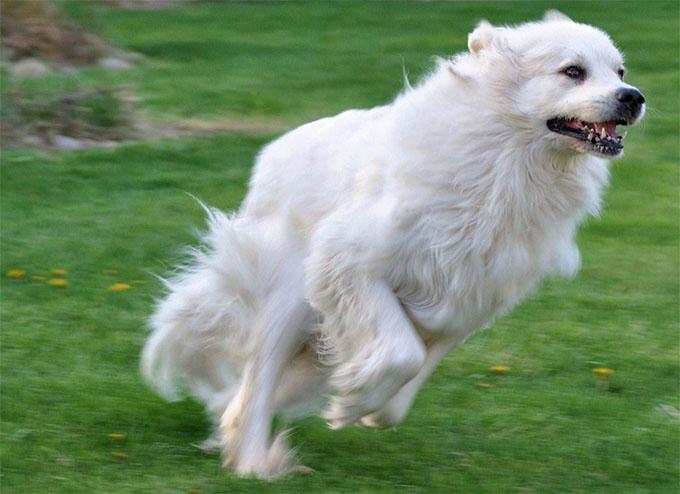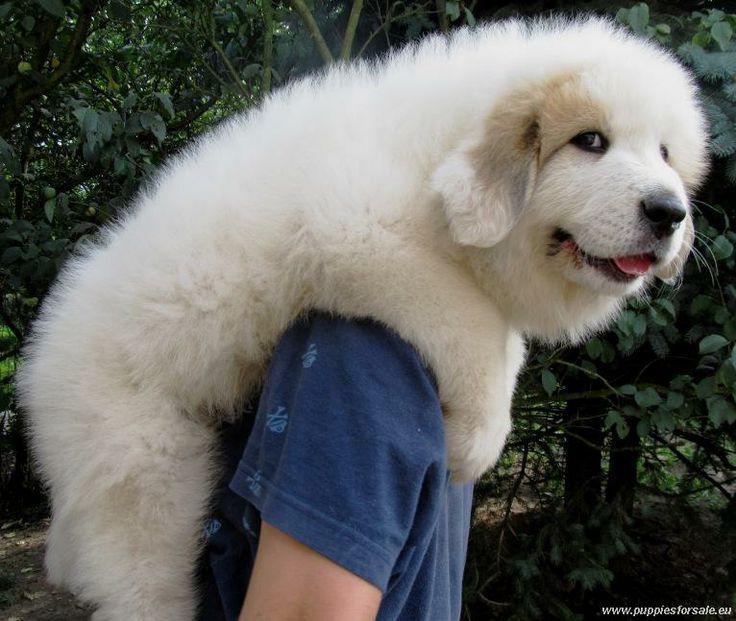The first image is the image on the left, the second image is the image on the right. Examine the images to the left and right. Is the description "dogs standing in a profile position facing to the left" accurate? Answer yes or no. No. The first image is the image on the left, the second image is the image on the right. Considering the images on both sides, is "The dog is interacting with a human in one picture." valid? Answer yes or no. Yes. 